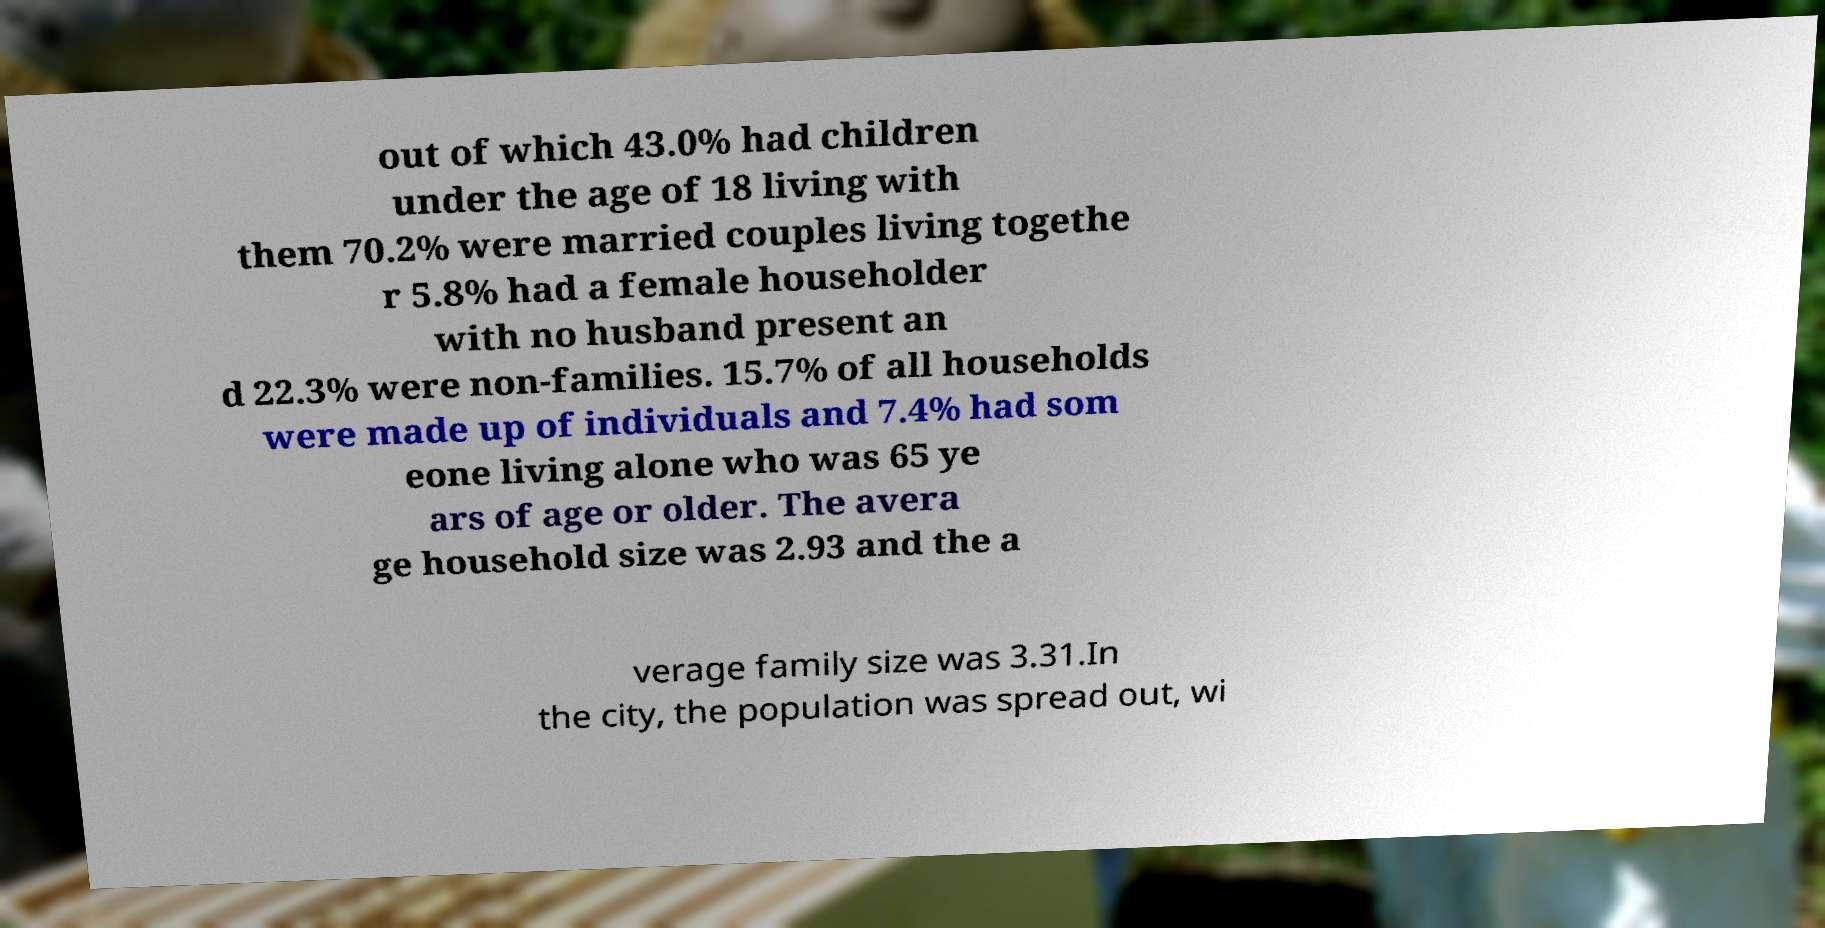Could you extract and type out the text from this image? out of which 43.0% had children under the age of 18 living with them 70.2% were married couples living togethe r 5.8% had a female householder with no husband present an d 22.3% were non-families. 15.7% of all households were made up of individuals and 7.4% had som eone living alone who was 65 ye ars of age or older. The avera ge household size was 2.93 and the a verage family size was 3.31.In the city, the population was spread out, wi 